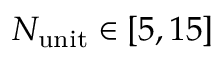<formula> <loc_0><loc_0><loc_500><loc_500>N _ { u n i t } \in [ 5 , 1 5 ]</formula> 